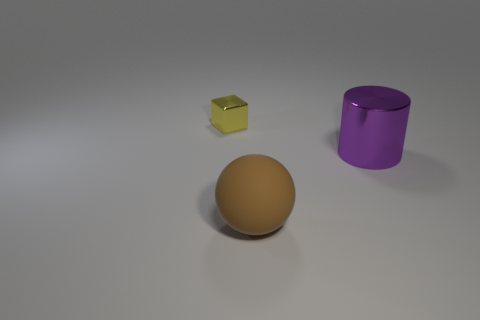Add 1 brown cylinders. How many objects exist? 4 Subtract all cubes. How many objects are left? 2 Add 2 yellow shiny blocks. How many yellow shiny blocks are left? 3 Add 1 small purple matte spheres. How many small purple matte spheres exist? 1 Subtract 0 yellow balls. How many objects are left? 3 Subtract all large rubber spheres. Subtract all gray balls. How many objects are left? 2 